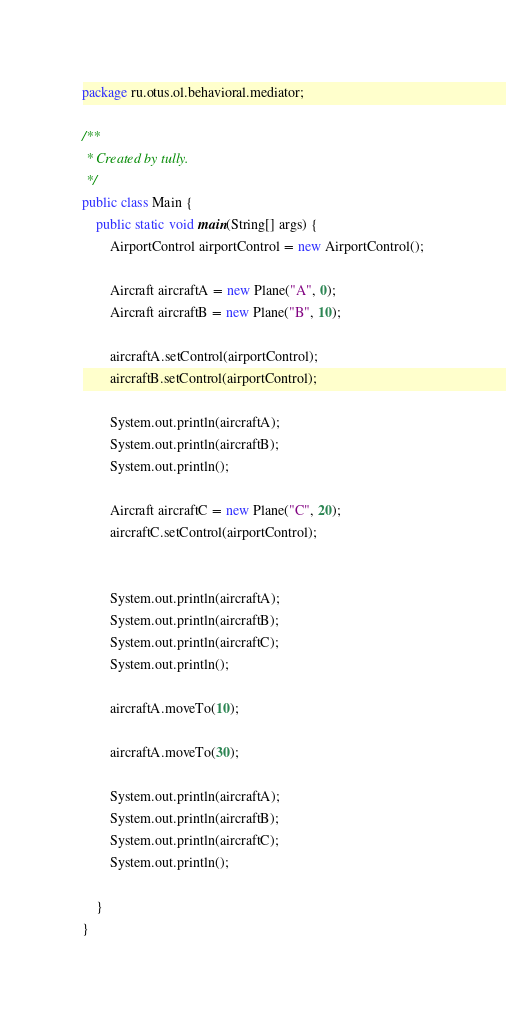Convert code to text. <code><loc_0><loc_0><loc_500><loc_500><_Java_>package ru.otus.ol.behavioral.mediator;

/**
 * Created by tully.
 */
public class Main {
    public static void main(String[] args) {
        AirportControl airportControl = new AirportControl();

        Aircraft aircraftA = new Plane("A", 0);
        Aircraft aircraftB = new Plane("B", 10);

        aircraftA.setControl(airportControl);
        aircraftB.setControl(airportControl);

        System.out.println(aircraftA);
        System.out.println(aircraftB);
        System.out.println();

        Aircraft aircraftC = new Plane("C", 20);
        aircraftC.setControl(airportControl);


        System.out.println(aircraftA);
        System.out.println(aircraftB);
        System.out.println(aircraftC);
        System.out.println();

        aircraftA.moveTo(10);

        aircraftA.moveTo(30);

        System.out.println(aircraftA);
        System.out.println(aircraftB);
        System.out.println(aircraftC);
        System.out.println();

    }
}
</code> 